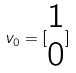Convert formula to latex. <formula><loc_0><loc_0><loc_500><loc_500>v _ { 0 } = [ \begin{matrix} 1 \\ 0 \end{matrix} ]</formula> 